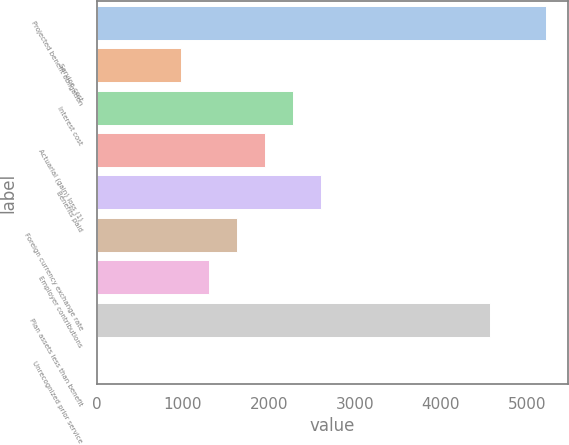Convert chart. <chart><loc_0><loc_0><loc_500><loc_500><bar_chart><fcel>Projected benefit obligation<fcel>Service cost<fcel>Interest cost<fcel>Actuarial (gain) loss (1)<fcel>Benefits paid<fcel>Foreign currency exchange rate<fcel>Employer contributions<fcel>Plan assets less than benefit<fcel>Unrecognized prior service<nl><fcel>5221.8<fcel>979.9<fcel>2285.1<fcel>1958.8<fcel>2611.4<fcel>1632.5<fcel>1306.2<fcel>4569.2<fcel>1<nl></chart> 